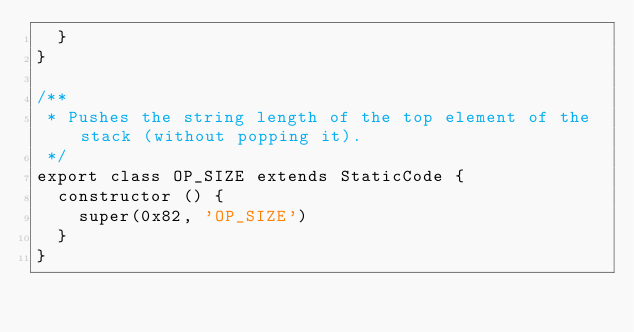Convert code to text. <code><loc_0><loc_0><loc_500><loc_500><_TypeScript_>  }
}

/**
 * Pushes the string length of the top element of the stack (without popping it).
 */
export class OP_SIZE extends StaticCode {
  constructor () {
    super(0x82, 'OP_SIZE')
  }
}
</code> 